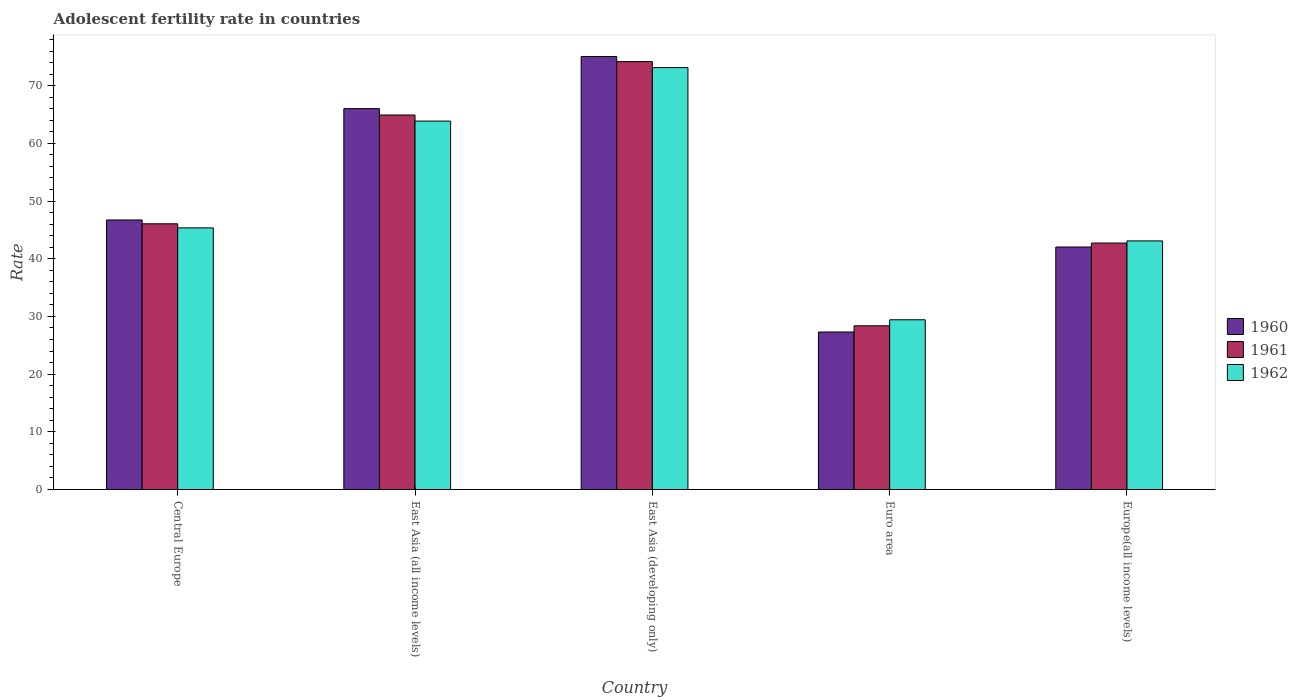How many bars are there on the 2nd tick from the right?
Offer a terse response. 3. What is the label of the 1st group of bars from the left?
Make the answer very short. Central Europe. What is the adolescent fertility rate in 1961 in Euro area?
Keep it short and to the point. 28.38. Across all countries, what is the maximum adolescent fertility rate in 1960?
Provide a short and direct response. 75.04. Across all countries, what is the minimum adolescent fertility rate in 1960?
Ensure brevity in your answer.  27.3. In which country was the adolescent fertility rate in 1960 maximum?
Provide a short and direct response. East Asia (developing only). In which country was the adolescent fertility rate in 1961 minimum?
Offer a very short reply. Euro area. What is the total adolescent fertility rate in 1962 in the graph?
Provide a succinct answer. 254.84. What is the difference between the adolescent fertility rate in 1960 in East Asia (all income levels) and that in Euro area?
Your response must be concise. 38.71. What is the difference between the adolescent fertility rate in 1961 in Europe(all income levels) and the adolescent fertility rate in 1962 in East Asia (developing only)?
Give a very brief answer. -30.41. What is the average adolescent fertility rate in 1962 per country?
Your answer should be very brief. 50.97. What is the difference between the adolescent fertility rate of/in 1960 and adolescent fertility rate of/in 1961 in Euro area?
Your response must be concise. -1.08. What is the ratio of the adolescent fertility rate in 1962 in Central Europe to that in Europe(all income levels)?
Ensure brevity in your answer.  1.05. What is the difference between the highest and the second highest adolescent fertility rate in 1961?
Offer a terse response. -9.25. What is the difference between the highest and the lowest adolescent fertility rate in 1960?
Provide a succinct answer. 47.74. Is the sum of the adolescent fertility rate in 1961 in East Asia (developing only) and Euro area greater than the maximum adolescent fertility rate in 1962 across all countries?
Keep it short and to the point. Yes. What does the 2nd bar from the left in East Asia (developing only) represents?
Ensure brevity in your answer.  1961. What does the 1st bar from the right in Europe(all income levels) represents?
Keep it short and to the point. 1962. How many bars are there?
Provide a short and direct response. 15. What is the difference between two consecutive major ticks on the Y-axis?
Provide a succinct answer. 10. Does the graph contain any zero values?
Provide a succinct answer. No. Where does the legend appear in the graph?
Your response must be concise. Center right. What is the title of the graph?
Offer a terse response. Adolescent fertility rate in countries. What is the label or title of the X-axis?
Your response must be concise. Country. What is the label or title of the Y-axis?
Ensure brevity in your answer.  Rate. What is the Rate in 1960 in Central Europe?
Offer a terse response. 46.72. What is the Rate in 1961 in Central Europe?
Offer a very short reply. 46.05. What is the Rate in 1962 in Central Europe?
Make the answer very short. 45.35. What is the Rate of 1960 in East Asia (all income levels)?
Keep it short and to the point. 66.02. What is the Rate in 1961 in East Asia (all income levels)?
Keep it short and to the point. 64.91. What is the Rate in 1962 in East Asia (all income levels)?
Your response must be concise. 63.86. What is the Rate of 1960 in East Asia (developing only)?
Offer a terse response. 75.04. What is the Rate in 1961 in East Asia (developing only)?
Your response must be concise. 74.16. What is the Rate of 1962 in East Asia (developing only)?
Offer a very short reply. 73.13. What is the Rate of 1960 in Euro area?
Your response must be concise. 27.3. What is the Rate in 1961 in Euro area?
Your answer should be compact. 28.38. What is the Rate of 1962 in Euro area?
Offer a terse response. 29.42. What is the Rate of 1960 in Europe(all income levels)?
Your response must be concise. 42.03. What is the Rate in 1961 in Europe(all income levels)?
Ensure brevity in your answer.  42.72. What is the Rate in 1962 in Europe(all income levels)?
Provide a short and direct response. 43.09. Across all countries, what is the maximum Rate of 1960?
Offer a terse response. 75.04. Across all countries, what is the maximum Rate in 1961?
Keep it short and to the point. 74.16. Across all countries, what is the maximum Rate of 1962?
Ensure brevity in your answer.  73.13. Across all countries, what is the minimum Rate of 1960?
Ensure brevity in your answer.  27.3. Across all countries, what is the minimum Rate of 1961?
Offer a terse response. 28.38. Across all countries, what is the minimum Rate in 1962?
Offer a very short reply. 29.42. What is the total Rate in 1960 in the graph?
Offer a very short reply. 257.11. What is the total Rate of 1961 in the graph?
Offer a very short reply. 256.22. What is the total Rate of 1962 in the graph?
Provide a short and direct response. 254.84. What is the difference between the Rate in 1960 in Central Europe and that in East Asia (all income levels)?
Ensure brevity in your answer.  -19.3. What is the difference between the Rate in 1961 in Central Europe and that in East Asia (all income levels)?
Your answer should be very brief. -18.86. What is the difference between the Rate of 1962 in Central Europe and that in East Asia (all income levels)?
Your answer should be very brief. -18.51. What is the difference between the Rate of 1960 in Central Europe and that in East Asia (developing only)?
Give a very brief answer. -28.33. What is the difference between the Rate in 1961 in Central Europe and that in East Asia (developing only)?
Your answer should be very brief. -28.11. What is the difference between the Rate in 1962 in Central Europe and that in East Asia (developing only)?
Provide a succinct answer. -27.78. What is the difference between the Rate of 1960 in Central Europe and that in Euro area?
Provide a succinct answer. 19.41. What is the difference between the Rate in 1961 in Central Europe and that in Euro area?
Offer a terse response. 17.68. What is the difference between the Rate in 1962 in Central Europe and that in Euro area?
Your answer should be very brief. 15.93. What is the difference between the Rate of 1960 in Central Europe and that in Europe(all income levels)?
Keep it short and to the point. 4.69. What is the difference between the Rate in 1961 in Central Europe and that in Europe(all income levels)?
Keep it short and to the point. 3.34. What is the difference between the Rate in 1962 in Central Europe and that in Europe(all income levels)?
Offer a terse response. 2.26. What is the difference between the Rate of 1960 in East Asia (all income levels) and that in East Asia (developing only)?
Make the answer very short. -9.03. What is the difference between the Rate of 1961 in East Asia (all income levels) and that in East Asia (developing only)?
Provide a succinct answer. -9.25. What is the difference between the Rate of 1962 in East Asia (all income levels) and that in East Asia (developing only)?
Keep it short and to the point. -9.27. What is the difference between the Rate of 1960 in East Asia (all income levels) and that in Euro area?
Keep it short and to the point. 38.71. What is the difference between the Rate of 1961 in East Asia (all income levels) and that in Euro area?
Ensure brevity in your answer.  36.53. What is the difference between the Rate in 1962 in East Asia (all income levels) and that in Euro area?
Ensure brevity in your answer.  34.44. What is the difference between the Rate of 1960 in East Asia (all income levels) and that in Europe(all income levels)?
Give a very brief answer. 23.99. What is the difference between the Rate in 1961 in East Asia (all income levels) and that in Europe(all income levels)?
Offer a terse response. 22.2. What is the difference between the Rate in 1962 in East Asia (all income levels) and that in Europe(all income levels)?
Your answer should be very brief. 20.77. What is the difference between the Rate of 1960 in East Asia (developing only) and that in Euro area?
Offer a very short reply. 47.74. What is the difference between the Rate of 1961 in East Asia (developing only) and that in Euro area?
Make the answer very short. 45.79. What is the difference between the Rate in 1962 in East Asia (developing only) and that in Euro area?
Provide a short and direct response. 43.7. What is the difference between the Rate of 1960 in East Asia (developing only) and that in Europe(all income levels)?
Offer a very short reply. 33.01. What is the difference between the Rate of 1961 in East Asia (developing only) and that in Europe(all income levels)?
Give a very brief answer. 31.45. What is the difference between the Rate of 1962 in East Asia (developing only) and that in Europe(all income levels)?
Ensure brevity in your answer.  30.04. What is the difference between the Rate of 1960 in Euro area and that in Europe(all income levels)?
Offer a very short reply. -14.73. What is the difference between the Rate of 1961 in Euro area and that in Europe(all income levels)?
Keep it short and to the point. -14.34. What is the difference between the Rate in 1962 in Euro area and that in Europe(all income levels)?
Your answer should be very brief. -13.67. What is the difference between the Rate in 1960 in Central Europe and the Rate in 1961 in East Asia (all income levels)?
Provide a short and direct response. -18.19. What is the difference between the Rate in 1960 in Central Europe and the Rate in 1962 in East Asia (all income levels)?
Provide a succinct answer. -17.14. What is the difference between the Rate in 1961 in Central Europe and the Rate in 1962 in East Asia (all income levels)?
Offer a very short reply. -17.8. What is the difference between the Rate in 1960 in Central Europe and the Rate in 1961 in East Asia (developing only)?
Offer a terse response. -27.45. What is the difference between the Rate in 1960 in Central Europe and the Rate in 1962 in East Asia (developing only)?
Make the answer very short. -26.41. What is the difference between the Rate in 1961 in Central Europe and the Rate in 1962 in East Asia (developing only)?
Offer a very short reply. -27.07. What is the difference between the Rate in 1960 in Central Europe and the Rate in 1961 in Euro area?
Your response must be concise. 18.34. What is the difference between the Rate in 1960 in Central Europe and the Rate in 1962 in Euro area?
Provide a short and direct response. 17.3. What is the difference between the Rate in 1961 in Central Europe and the Rate in 1962 in Euro area?
Make the answer very short. 16.63. What is the difference between the Rate in 1960 in Central Europe and the Rate in 1961 in Europe(all income levels)?
Your response must be concise. 4. What is the difference between the Rate in 1960 in Central Europe and the Rate in 1962 in Europe(all income levels)?
Provide a succinct answer. 3.63. What is the difference between the Rate of 1961 in Central Europe and the Rate of 1962 in Europe(all income levels)?
Keep it short and to the point. 2.97. What is the difference between the Rate of 1960 in East Asia (all income levels) and the Rate of 1961 in East Asia (developing only)?
Offer a terse response. -8.15. What is the difference between the Rate of 1960 in East Asia (all income levels) and the Rate of 1962 in East Asia (developing only)?
Provide a short and direct response. -7.11. What is the difference between the Rate of 1961 in East Asia (all income levels) and the Rate of 1962 in East Asia (developing only)?
Provide a succinct answer. -8.21. What is the difference between the Rate in 1960 in East Asia (all income levels) and the Rate in 1961 in Euro area?
Offer a very short reply. 37.64. What is the difference between the Rate in 1960 in East Asia (all income levels) and the Rate in 1962 in Euro area?
Offer a very short reply. 36.6. What is the difference between the Rate in 1961 in East Asia (all income levels) and the Rate in 1962 in Euro area?
Keep it short and to the point. 35.49. What is the difference between the Rate in 1960 in East Asia (all income levels) and the Rate in 1961 in Europe(all income levels)?
Ensure brevity in your answer.  23.3. What is the difference between the Rate in 1960 in East Asia (all income levels) and the Rate in 1962 in Europe(all income levels)?
Your answer should be compact. 22.93. What is the difference between the Rate of 1961 in East Asia (all income levels) and the Rate of 1962 in Europe(all income levels)?
Make the answer very short. 21.82. What is the difference between the Rate in 1960 in East Asia (developing only) and the Rate in 1961 in Euro area?
Offer a terse response. 46.67. What is the difference between the Rate in 1960 in East Asia (developing only) and the Rate in 1962 in Euro area?
Make the answer very short. 45.62. What is the difference between the Rate of 1961 in East Asia (developing only) and the Rate of 1962 in Euro area?
Offer a terse response. 44.74. What is the difference between the Rate of 1960 in East Asia (developing only) and the Rate of 1961 in Europe(all income levels)?
Your response must be concise. 32.33. What is the difference between the Rate in 1960 in East Asia (developing only) and the Rate in 1962 in Europe(all income levels)?
Provide a short and direct response. 31.96. What is the difference between the Rate in 1961 in East Asia (developing only) and the Rate in 1962 in Europe(all income levels)?
Your answer should be compact. 31.07. What is the difference between the Rate in 1960 in Euro area and the Rate in 1961 in Europe(all income levels)?
Make the answer very short. -15.41. What is the difference between the Rate of 1960 in Euro area and the Rate of 1962 in Europe(all income levels)?
Provide a succinct answer. -15.79. What is the difference between the Rate of 1961 in Euro area and the Rate of 1962 in Europe(all income levels)?
Provide a succinct answer. -14.71. What is the average Rate of 1960 per country?
Provide a short and direct response. 51.42. What is the average Rate of 1961 per country?
Your response must be concise. 51.24. What is the average Rate of 1962 per country?
Ensure brevity in your answer.  50.97. What is the difference between the Rate of 1960 and Rate of 1961 in Central Europe?
Give a very brief answer. 0.66. What is the difference between the Rate of 1960 and Rate of 1962 in Central Europe?
Ensure brevity in your answer.  1.37. What is the difference between the Rate of 1961 and Rate of 1962 in Central Europe?
Your answer should be compact. 0.71. What is the difference between the Rate in 1960 and Rate in 1961 in East Asia (all income levels)?
Give a very brief answer. 1.11. What is the difference between the Rate of 1960 and Rate of 1962 in East Asia (all income levels)?
Ensure brevity in your answer.  2.16. What is the difference between the Rate in 1961 and Rate in 1962 in East Asia (all income levels)?
Provide a succinct answer. 1.05. What is the difference between the Rate of 1960 and Rate of 1961 in East Asia (developing only)?
Provide a short and direct response. 0.88. What is the difference between the Rate in 1960 and Rate in 1962 in East Asia (developing only)?
Your answer should be very brief. 1.92. What is the difference between the Rate in 1961 and Rate in 1962 in East Asia (developing only)?
Provide a short and direct response. 1.04. What is the difference between the Rate in 1960 and Rate in 1961 in Euro area?
Provide a succinct answer. -1.08. What is the difference between the Rate in 1960 and Rate in 1962 in Euro area?
Offer a very short reply. -2.12. What is the difference between the Rate in 1961 and Rate in 1962 in Euro area?
Keep it short and to the point. -1.04. What is the difference between the Rate of 1960 and Rate of 1961 in Europe(all income levels)?
Provide a succinct answer. -0.69. What is the difference between the Rate in 1960 and Rate in 1962 in Europe(all income levels)?
Give a very brief answer. -1.06. What is the difference between the Rate in 1961 and Rate in 1962 in Europe(all income levels)?
Your answer should be compact. -0.37. What is the ratio of the Rate of 1960 in Central Europe to that in East Asia (all income levels)?
Keep it short and to the point. 0.71. What is the ratio of the Rate of 1961 in Central Europe to that in East Asia (all income levels)?
Provide a succinct answer. 0.71. What is the ratio of the Rate of 1962 in Central Europe to that in East Asia (all income levels)?
Your answer should be compact. 0.71. What is the ratio of the Rate of 1960 in Central Europe to that in East Asia (developing only)?
Provide a short and direct response. 0.62. What is the ratio of the Rate of 1961 in Central Europe to that in East Asia (developing only)?
Offer a very short reply. 0.62. What is the ratio of the Rate of 1962 in Central Europe to that in East Asia (developing only)?
Provide a succinct answer. 0.62. What is the ratio of the Rate of 1960 in Central Europe to that in Euro area?
Keep it short and to the point. 1.71. What is the ratio of the Rate in 1961 in Central Europe to that in Euro area?
Your answer should be very brief. 1.62. What is the ratio of the Rate of 1962 in Central Europe to that in Euro area?
Give a very brief answer. 1.54. What is the ratio of the Rate in 1960 in Central Europe to that in Europe(all income levels)?
Provide a succinct answer. 1.11. What is the ratio of the Rate of 1961 in Central Europe to that in Europe(all income levels)?
Your response must be concise. 1.08. What is the ratio of the Rate of 1962 in Central Europe to that in Europe(all income levels)?
Provide a short and direct response. 1.05. What is the ratio of the Rate in 1960 in East Asia (all income levels) to that in East Asia (developing only)?
Your answer should be compact. 0.88. What is the ratio of the Rate of 1961 in East Asia (all income levels) to that in East Asia (developing only)?
Make the answer very short. 0.88. What is the ratio of the Rate of 1962 in East Asia (all income levels) to that in East Asia (developing only)?
Offer a terse response. 0.87. What is the ratio of the Rate in 1960 in East Asia (all income levels) to that in Euro area?
Keep it short and to the point. 2.42. What is the ratio of the Rate in 1961 in East Asia (all income levels) to that in Euro area?
Provide a short and direct response. 2.29. What is the ratio of the Rate of 1962 in East Asia (all income levels) to that in Euro area?
Your response must be concise. 2.17. What is the ratio of the Rate in 1960 in East Asia (all income levels) to that in Europe(all income levels)?
Your response must be concise. 1.57. What is the ratio of the Rate of 1961 in East Asia (all income levels) to that in Europe(all income levels)?
Offer a terse response. 1.52. What is the ratio of the Rate in 1962 in East Asia (all income levels) to that in Europe(all income levels)?
Your answer should be very brief. 1.48. What is the ratio of the Rate of 1960 in East Asia (developing only) to that in Euro area?
Your answer should be compact. 2.75. What is the ratio of the Rate in 1961 in East Asia (developing only) to that in Euro area?
Your answer should be very brief. 2.61. What is the ratio of the Rate in 1962 in East Asia (developing only) to that in Euro area?
Provide a short and direct response. 2.49. What is the ratio of the Rate of 1960 in East Asia (developing only) to that in Europe(all income levels)?
Provide a short and direct response. 1.79. What is the ratio of the Rate of 1961 in East Asia (developing only) to that in Europe(all income levels)?
Your response must be concise. 1.74. What is the ratio of the Rate of 1962 in East Asia (developing only) to that in Europe(all income levels)?
Your answer should be compact. 1.7. What is the ratio of the Rate of 1960 in Euro area to that in Europe(all income levels)?
Your answer should be compact. 0.65. What is the ratio of the Rate in 1961 in Euro area to that in Europe(all income levels)?
Provide a short and direct response. 0.66. What is the ratio of the Rate in 1962 in Euro area to that in Europe(all income levels)?
Offer a very short reply. 0.68. What is the difference between the highest and the second highest Rate in 1960?
Offer a terse response. 9.03. What is the difference between the highest and the second highest Rate of 1961?
Your answer should be compact. 9.25. What is the difference between the highest and the second highest Rate of 1962?
Provide a succinct answer. 9.27. What is the difference between the highest and the lowest Rate of 1960?
Give a very brief answer. 47.74. What is the difference between the highest and the lowest Rate in 1961?
Ensure brevity in your answer.  45.79. What is the difference between the highest and the lowest Rate of 1962?
Provide a succinct answer. 43.7. 